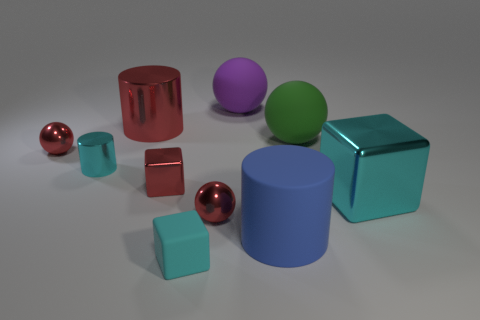There is a big red thing that is the same shape as the tiny cyan shiny object; what is it made of?
Offer a very short reply. Metal. There is a red cylinder that is made of the same material as the big cube; what size is it?
Provide a short and direct response. Large. The large matte ball that is to the left of the big blue matte object is what color?
Offer a terse response. Purple. There is a cube that is right of the purple matte object; is its size the same as the small metal cylinder?
Ensure brevity in your answer.  No. Is the number of big cubes less than the number of gray cubes?
Offer a very short reply. No. There is a large thing that is the same color as the tiny metal block; what shape is it?
Your response must be concise. Cylinder. How many metallic spheres are in front of the big cyan metallic block?
Your answer should be very brief. 1. Does the blue object have the same shape as the small cyan shiny thing?
Offer a terse response. Yes. How many cylinders are both on the right side of the small metallic cylinder and in front of the green rubber thing?
Give a very brief answer. 1. What number of objects are either blocks or big cylinders to the left of the big purple matte thing?
Ensure brevity in your answer.  4. 